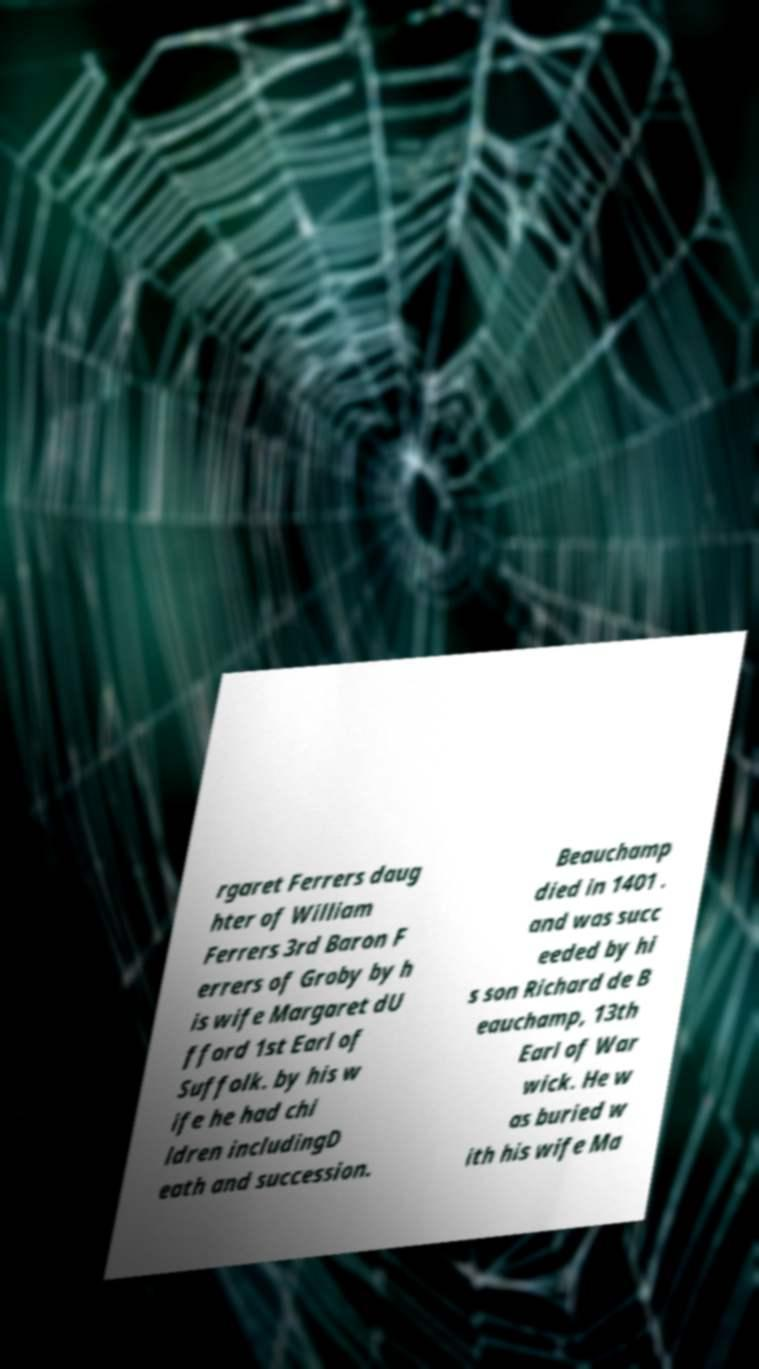Could you assist in decoding the text presented in this image and type it out clearly? rgaret Ferrers daug hter of William Ferrers 3rd Baron F errers of Groby by h is wife Margaret dU fford 1st Earl of Suffolk. by his w ife he had chi ldren includingD eath and succession. Beauchamp died in 1401 . and was succ eeded by hi s son Richard de B eauchamp, 13th Earl of War wick. He w as buried w ith his wife Ma 